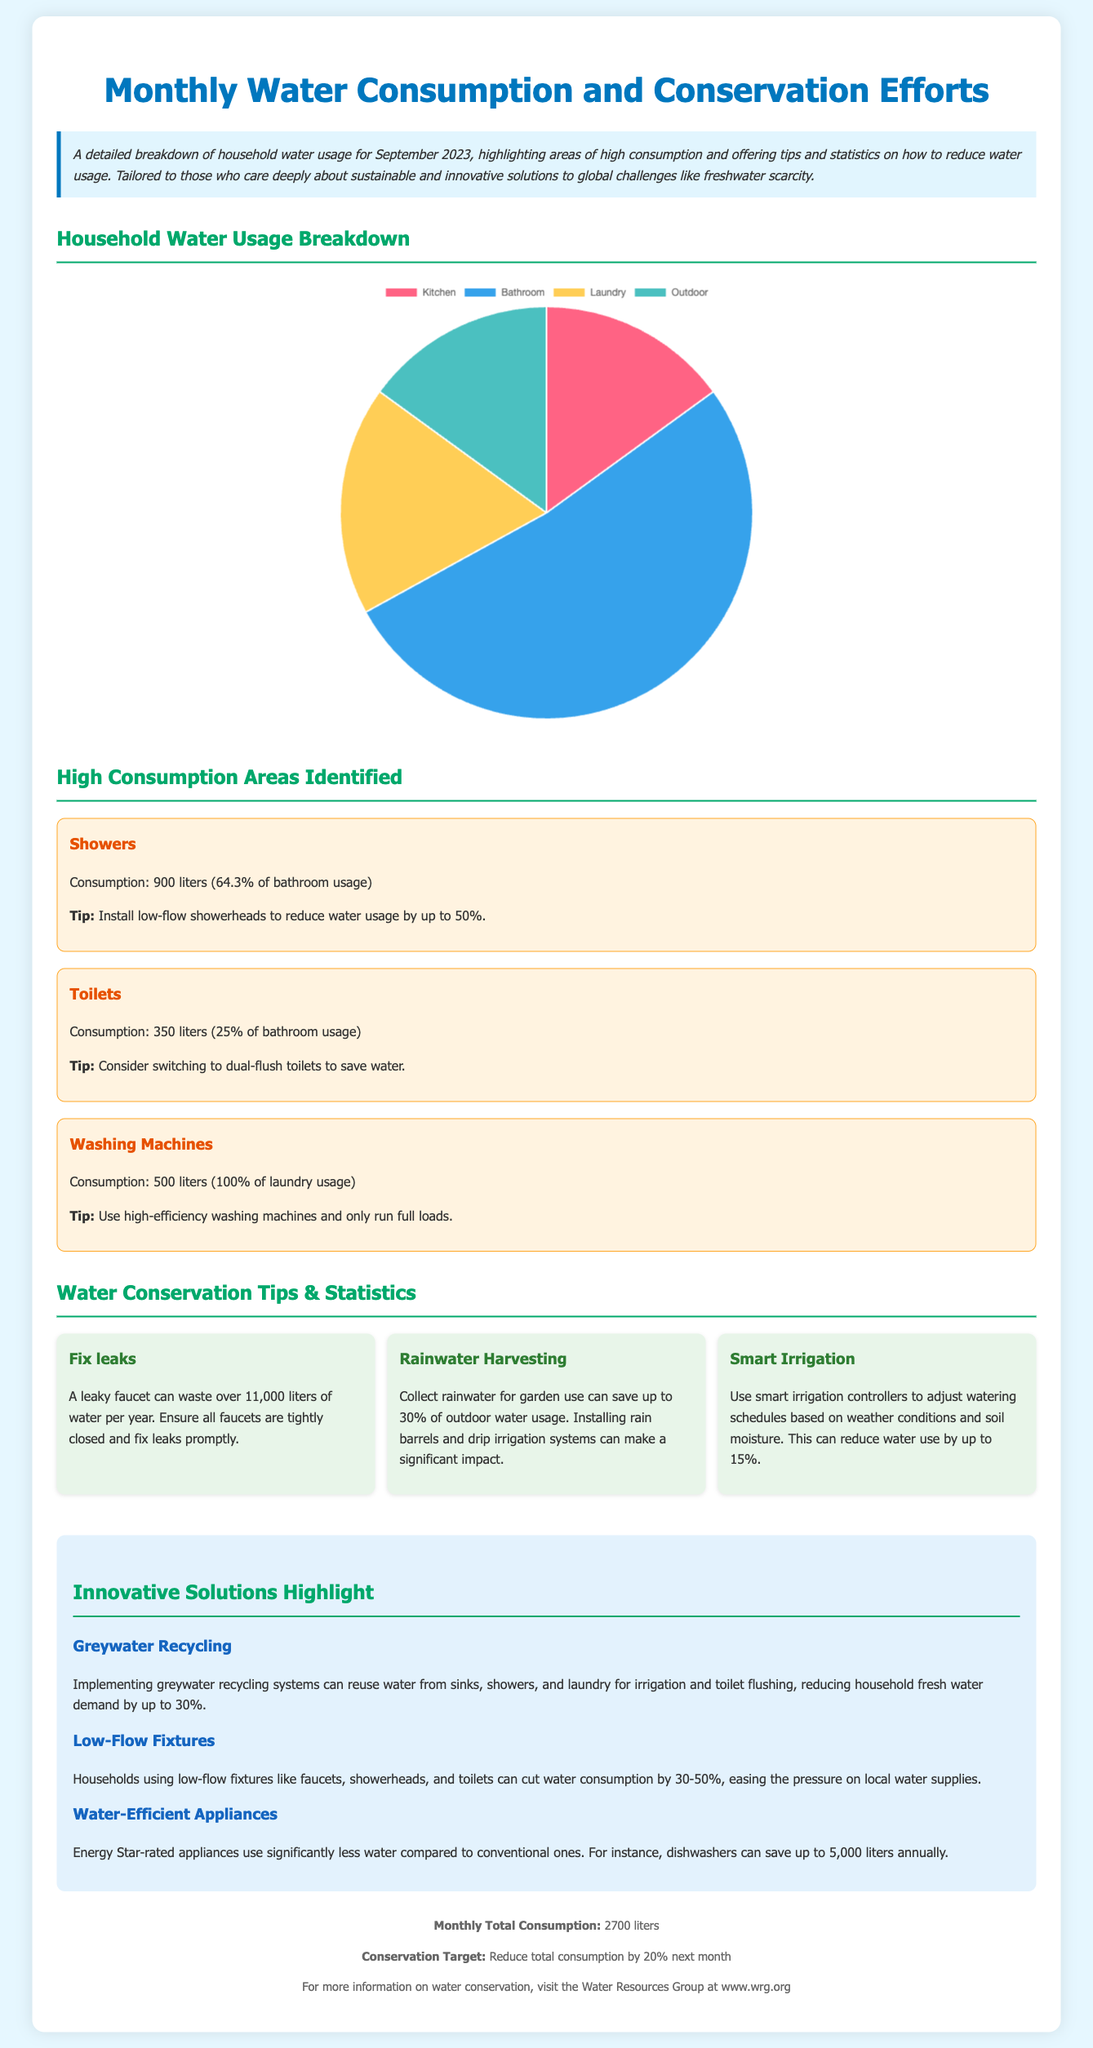What is the total monthly water consumption? The total monthly water consumption is clearly stated in the footer of the document.
Answer: 2700 liters What percentage of bathroom usage is attributed to showers? The document specifies the percentage of bathroom usage for showers in the high consumption section.
Answer: 64.3% What is one suggested tip for reducing shower water consumption? The document provides tips on specific high consumption areas, particularly for showers.
Answer: Install low-flow showerheads How much water can a leaky faucet waste per year? The tip section details the waste of water due to a leaky faucet.
Answer: over 11,000 liters What is the conservation target for next month? The footer of the document states the conservation target for the household.
Answer: Reduce total consumption by 20% What are the four categories shown in the household water usage pie chart? The document lists categories of water usage in the pie chart.
Answer: Kitchen, Bathroom, Laundry, Outdoor How much water do washing machines consume according to the report? The report specifies the water consumption for washing machines in the high consumption section.
Answer: 500 liters What innovative solution can reduce household fresh water demand by up to 30%? The document highlights various innovative solutions to tackle water demand.
Answer: Greywater Recycling 